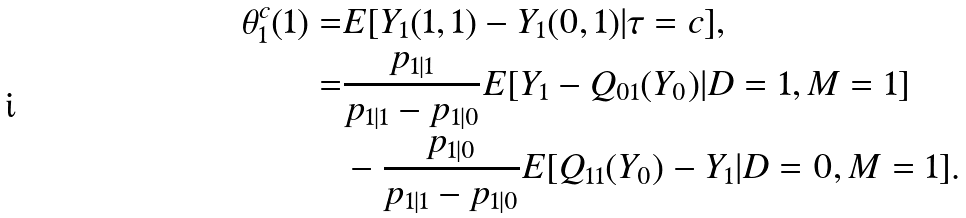Convert formula to latex. <formula><loc_0><loc_0><loc_500><loc_500>\theta _ { 1 } ^ { c } ( 1 ) = & E [ Y _ { 1 } ( 1 , 1 ) - Y _ { 1 } ( 0 , 1 ) | \tau = c ] , \\ = & \frac { p _ { 1 | 1 } } { p _ { 1 | 1 } - p _ { 1 | 0 } } E [ Y _ { 1 } - Q _ { 0 1 } ( Y _ { 0 } ) | D = 1 , M = 1 ] \\ & - \frac { p _ { 1 | 0 } } { p _ { 1 | 1 } - p _ { 1 | 0 } } E [ Q _ { 1 1 } ( Y _ { 0 } ) - Y _ { 1 } | D = 0 , M = 1 ] .</formula> 